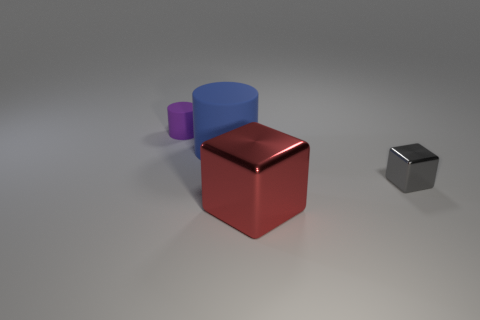What is the small purple object made of?
Ensure brevity in your answer.  Rubber. The large object behind the tiny thing on the right side of the matte cylinder that is in front of the purple rubber cylinder is made of what material?
Keep it short and to the point. Rubber. There is a tiny gray metal object; is it the same shape as the large object that is on the right side of the blue rubber object?
Ensure brevity in your answer.  Yes. There is a small object in front of the big thing that is behind the red metal thing; how many blue cylinders are to the left of it?
Provide a succinct answer. 1. What size is the metallic block that is in front of the small object to the right of the tiny cylinder?
Ensure brevity in your answer.  Large. There is a thing that is made of the same material as the small gray cube; what size is it?
Give a very brief answer. Large. What is the shape of the object that is in front of the large cylinder and behind the red shiny object?
Provide a succinct answer. Cube. Are there the same number of small rubber things that are left of the tiny block and tiny green things?
Your response must be concise. No. What number of things are yellow matte cylinders or tiny things on the left side of the red block?
Ensure brevity in your answer.  1. Are there any blue objects that have the same shape as the purple object?
Your response must be concise. Yes. 